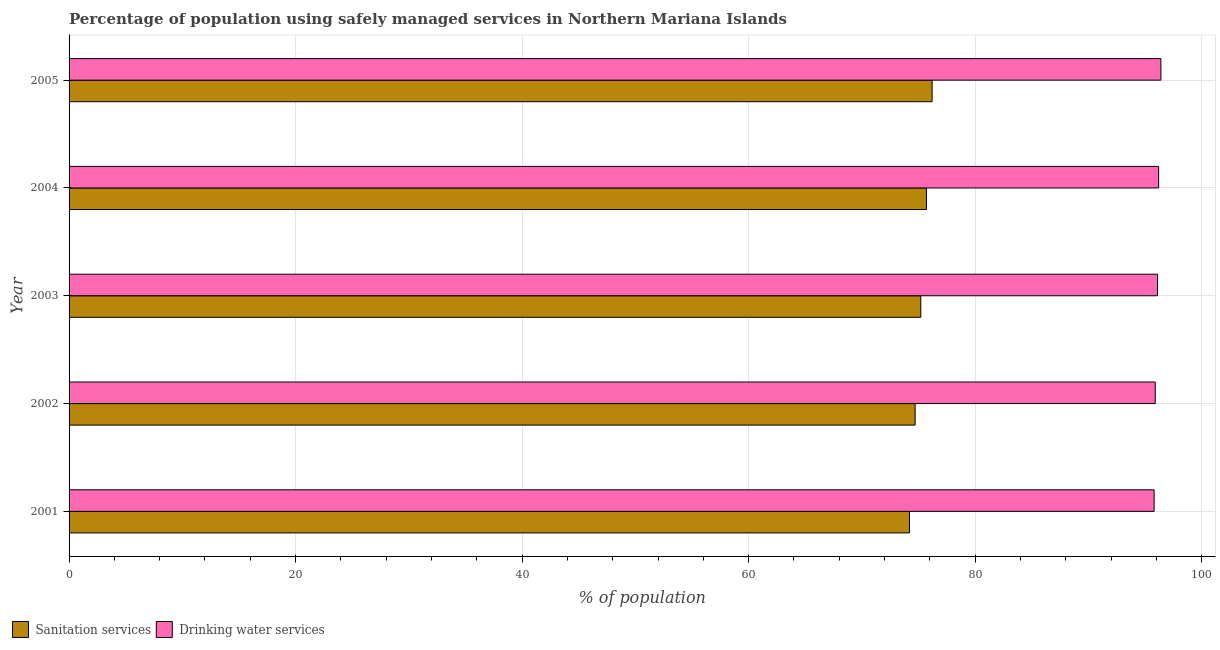How many different coloured bars are there?
Your answer should be compact. 2. In how many cases, is the number of bars for a given year not equal to the number of legend labels?
Keep it short and to the point. 0. What is the percentage of population who used sanitation services in 2001?
Ensure brevity in your answer.  74.2. Across all years, what is the maximum percentage of population who used drinking water services?
Provide a succinct answer. 96.4. Across all years, what is the minimum percentage of population who used drinking water services?
Give a very brief answer. 95.8. In which year was the percentage of population who used sanitation services minimum?
Ensure brevity in your answer.  2001. What is the total percentage of population who used sanitation services in the graph?
Provide a succinct answer. 376. What is the difference between the percentage of population who used sanitation services in 2001 and that in 2004?
Your response must be concise. -1.5. What is the difference between the percentage of population who used drinking water services in 2002 and the percentage of population who used sanitation services in 2001?
Ensure brevity in your answer.  21.7. What is the average percentage of population who used drinking water services per year?
Offer a terse response. 96.08. In the year 2005, what is the difference between the percentage of population who used sanitation services and percentage of population who used drinking water services?
Offer a terse response. -20.2. In how many years, is the percentage of population who used sanitation services greater than 8 %?
Your answer should be very brief. 5. What is the ratio of the percentage of population who used sanitation services in 2001 to that in 2002?
Your answer should be compact. 0.99. Is the percentage of population who used drinking water services in 2001 less than that in 2002?
Give a very brief answer. Yes. Is the difference between the percentage of population who used drinking water services in 2002 and 2005 greater than the difference between the percentage of population who used sanitation services in 2002 and 2005?
Provide a short and direct response. Yes. What is the difference between the highest and the second highest percentage of population who used sanitation services?
Your answer should be very brief. 0.5. What is the difference between the highest and the lowest percentage of population who used drinking water services?
Your response must be concise. 0.6. Is the sum of the percentage of population who used sanitation services in 2001 and 2003 greater than the maximum percentage of population who used drinking water services across all years?
Keep it short and to the point. Yes. What does the 2nd bar from the top in 2005 represents?
Keep it short and to the point. Sanitation services. What does the 2nd bar from the bottom in 2004 represents?
Give a very brief answer. Drinking water services. How many bars are there?
Make the answer very short. 10. What is the difference between two consecutive major ticks on the X-axis?
Your response must be concise. 20. How many legend labels are there?
Give a very brief answer. 2. What is the title of the graph?
Your answer should be compact. Percentage of population using safely managed services in Northern Mariana Islands. What is the label or title of the X-axis?
Provide a short and direct response. % of population. What is the label or title of the Y-axis?
Ensure brevity in your answer.  Year. What is the % of population of Sanitation services in 2001?
Ensure brevity in your answer.  74.2. What is the % of population in Drinking water services in 2001?
Provide a short and direct response. 95.8. What is the % of population of Sanitation services in 2002?
Provide a short and direct response. 74.7. What is the % of population in Drinking water services in 2002?
Ensure brevity in your answer.  95.9. What is the % of population of Sanitation services in 2003?
Provide a succinct answer. 75.2. What is the % of population of Drinking water services in 2003?
Make the answer very short. 96.1. What is the % of population of Sanitation services in 2004?
Ensure brevity in your answer.  75.7. What is the % of population in Drinking water services in 2004?
Your answer should be compact. 96.2. What is the % of population of Sanitation services in 2005?
Give a very brief answer. 76.2. What is the % of population in Drinking water services in 2005?
Provide a succinct answer. 96.4. Across all years, what is the maximum % of population of Sanitation services?
Provide a short and direct response. 76.2. Across all years, what is the maximum % of population of Drinking water services?
Provide a succinct answer. 96.4. Across all years, what is the minimum % of population of Sanitation services?
Provide a short and direct response. 74.2. Across all years, what is the minimum % of population of Drinking water services?
Offer a terse response. 95.8. What is the total % of population of Sanitation services in the graph?
Keep it short and to the point. 376. What is the total % of population of Drinking water services in the graph?
Provide a succinct answer. 480.4. What is the difference between the % of population in Drinking water services in 2001 and that in 2003?
Provide a succinct answer. -0.3. What is the difference between the % of population of Drinking water services in 2001 and that in 2004?
Provide a short and direct response. -0.4. What is the difference between the % of population of Sanitation services in 2001 and that in 2005?
Provide a short and direct response. -2. What is the difference between the % of population of Drinking water services in 2001 and that in 2005?
Your answer should be very brief. -0.6. What is the difference between the % of population in Sanitation services in 2002 and that in 2003?
Offer a terse response. -0.5. What is the difference between the % of population in Drinking water services in 2002 and that in 2003?
Your answer should be very brief. -0.2. What is the difference between the % of population of Drinking water services in 2002 and that in 2004?
Provide a succinct answer. -0.3. What is the difference between the % of population of Drinking water services in 2004 and that in 2005?
Give a very brief answer. -0.2. What is the difference between the % of population in Sanitation services in 2001 and the % of population in Drinking water services in 2002?
Provide a short and direct response. -21.7. What is the difference between the % of population in Sanitation services in 2001 and the % of population in Drinking water services in 2003?
Offer a very short reply. -21.9. What is the difference between the % of population in Sanitation services in 2001 and the % of population in Drinking water services in 2004?
Your answer should be compact. -22. What is the difference between the % of population in Sanitation services in 2001 and the % of population in Drinking water services in 2005?
Make the answer very short. -22.2. What is the difference between the % of population of Sanitation services in 2002 and the % of population of Drinking water services in 2003?
Give a very brief answer. -21.4. What is the difference between the % of population in Sanitation services in 2002 and the % of population in Drinking water services in 2004?
Provide a short and direct response. -21.5. What is the difference between the % of population of Sanitation services in 2002 and the % of population of Drinking water services in 2005?
Keep it short and to the point. -21.7. What is the difference between the % of population in Sanitation services in 2003 and the % of population in Drinking water services in 2004?
Make the answer very short. -21. What is the difference between the % of population of Sanitation services in 2003 and the % of population of Drinking water services in 2005?
Provide a succinct answer. -21.2. What is the difference between the % of population of Sanitation services in 2004 and the % of population of Drinking water services in 2005?
Your response must be concise. -20.7. What is the average % of population of Sanitation services per year?
Provide a succinct answer. 75.2. What is the average % of population in Drinking water services per year?
Your answer should be compact. 96.08. In the year 2001, what is the difference between the % of population of Sanitation services and % of population of Drinking water services?
Your answer should be compact. -21.6. In the year 2002, what is the difference between the % of population of Sanitation services and % of population of Drinking water services?
Provide a short and direct response. -21.2. In the year 2003, what is the difference between the % of population of Sanitation services and % of population of Drinking water services?
Make the answer very short. -20.9. In the year 2004, what is the difference between the % of population in Sanitation services and % of population in Drinking water services?
Offer a very short reply. -20.5. In the year 2005, what is the difference between the % of population of Sanitation services and % of population of Drinking water services?
Your response must be concise. -20.2. What is the ratio of the % of population of Sanitation services in 2001 to that in 2002?
Provide a short and direct response. 0.99. What is the ratio of the % of population in Sanitation services in 2001 to that in 2003?
Make the answer very short. 0.99. What is the ratio of the % of population in Sanitation services in 2001 to that in 2004?
Offer a very short reply. 0.98. What is the ratio of the % of population in Sanitation services in 2001 to that in 2005?
Offer a terse response. 0.97. What is the ratio of the % of population in Drinking water services in 2001 to that in 2005?
Offer a terse response. 0.99. What is the ratio of the % of population in Drinking water services in 2002 to that in 2003?
Provide a succinct answer. 1. What is the ratio of the % of population of Sanitation services in 2002 to that in 2004?
Keep it short and to the point. 0.99. What is the ratio of the % of population in Drinking water services in 2002 to that in 2004?
Offer a terse response. 1. What is the ratio of the % of population in Sanitation services in 2002 to that in 2005?
Your answer should be compact. 0.98. What is the ratio of the % of population in Sanitation services in 2003 to that in 2004?
Your response must be concise. 0.99. What is the ratio of the % of population in Sanitation services in 2003 to that in 2005?
Give a very brief answer. 0.99. What is the ratio of the % of population in Sanitation services in 2004 to that in 2005?
Ensure brevity in your answer.  0.99. What is the difference between the highest and the second highest % of population of Sanitation services?
Make the answer very short. 0.5. What is the difference between the highest and the second highest % of population in Drinking water services?
Your answer should be very brief. 0.2. 